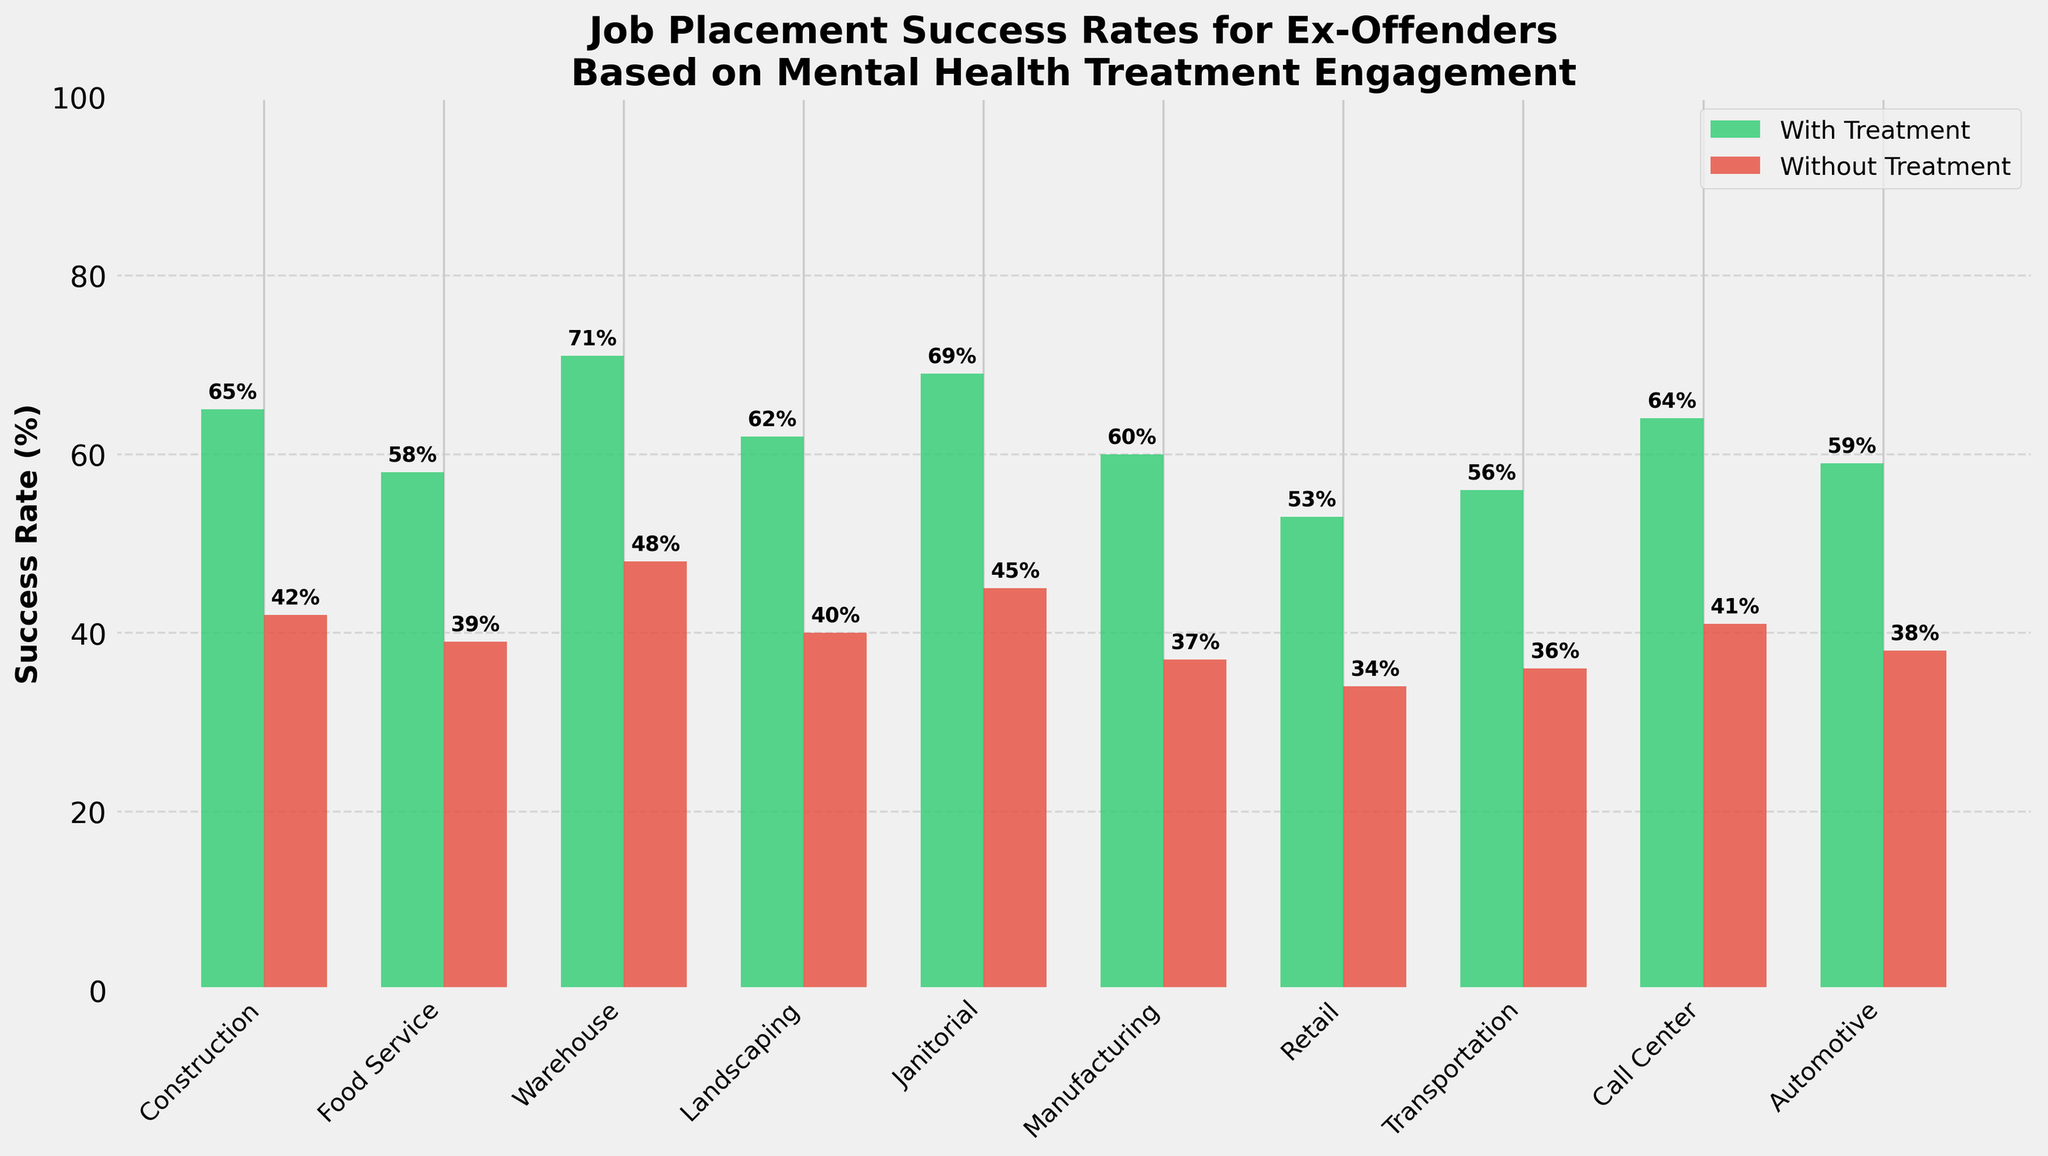Which job type has the highest job placement success rate for those without treatment? By visually examining the height of the red bars representing "Without Treatment" for all job types, the "Warehouse" job type has the highest success rate.
Answer: Warehouse What is the difference in job placement success rates for those with and without treatment in Food Service? The success rate with treatment in Food Service is 58% and without treatment is 39%. The difference is 58% - 39% = 19%.
Answer: 19% How many job categories have a job placement success rate with treatment that is above 60%? Visually inspecting the green bars, the job categories with success rates above 60% are Construction, Warehouse, Landscaping, Janitorial, and Call Center, making it a total of 5 categories.
Answer: 5 Which job type shows the smallest difference in job placement success rates between those with and without treatment? By calculating the differences for each job type, "Transportation" has the smallest difference, with rates being 56% (with treatment) and 36% (without treatment), so the difference is 20%.
Answer: Transportation In which job categories do the job placement success rates for those without treatment fall below 40%? The red bars representing "Without Treatment" below 40% correspond to Food Service (39%), Manufacturing (37%), Retail (34%), and Transportation (36%).
Answer: Food Service, Manufacturing, Retail, Transportation Among Call Center and Automotive job types, which one has a higher job placement success rate without treatment? Visual inspection of the red bars shows that the Call Center has a placement rate of 41% and Automotive has a placement rate of 38%. Call Center is higher.
Answer: Call Center What is the average job placement success rate for those with treatment in the Janitorial, Manufacturing, and Retail categories? The success rates with treatment are 69% for Janitorial, 60% for Manufacturing, and 53% for Retail. The average is (69 + 60 + 53) / 3 = 60.67%.
Answer: 60.67% Is the job placement success rate for those with treatment higher in Landscaping or Construction? By comparing the heights of the green bars, Construction has a higher success rate of 65% compared to Landscaping, which has 62%.
Answer: Construction Which has a greater job placement success rate without treatment: Manufacturing or Retail? Visually inspecting the red bars, Manufacturing has a rate of 37% and Retail has a rate of 34%. Manufacturing is greater.
Answer: Manufacturing What is the median job placement success rate for those with treatment across all job categories? The sorted success rates for those with treatment are 53%, 56%, 58%, 59%, 60%, 62%, 64%, 65%, 69%, and 71%. The median value, being the middle value in an ordered list, is the average of the 5th and 6th values, (60% + 62%) / 2 = 61%.
Answer: 61% 